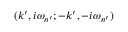<formula> <loc_0><loc_0><loc_500><loc_500>( k ^ { \prime } , i \omega _ { n ^ { \prime } } ; - k ^ { \prime } , - i \omega _ { n ^ { \prime } } )</formula> 